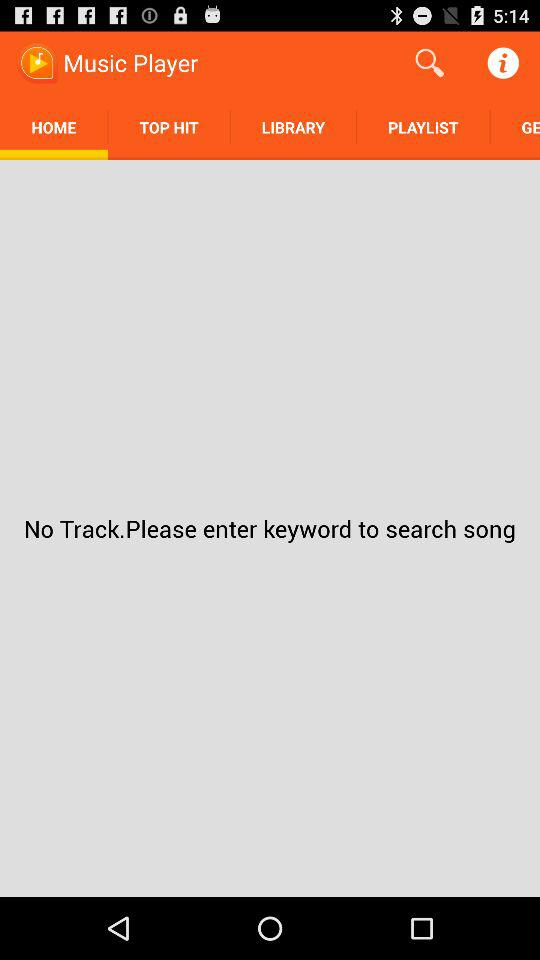Is there any track available? There is no track available. 